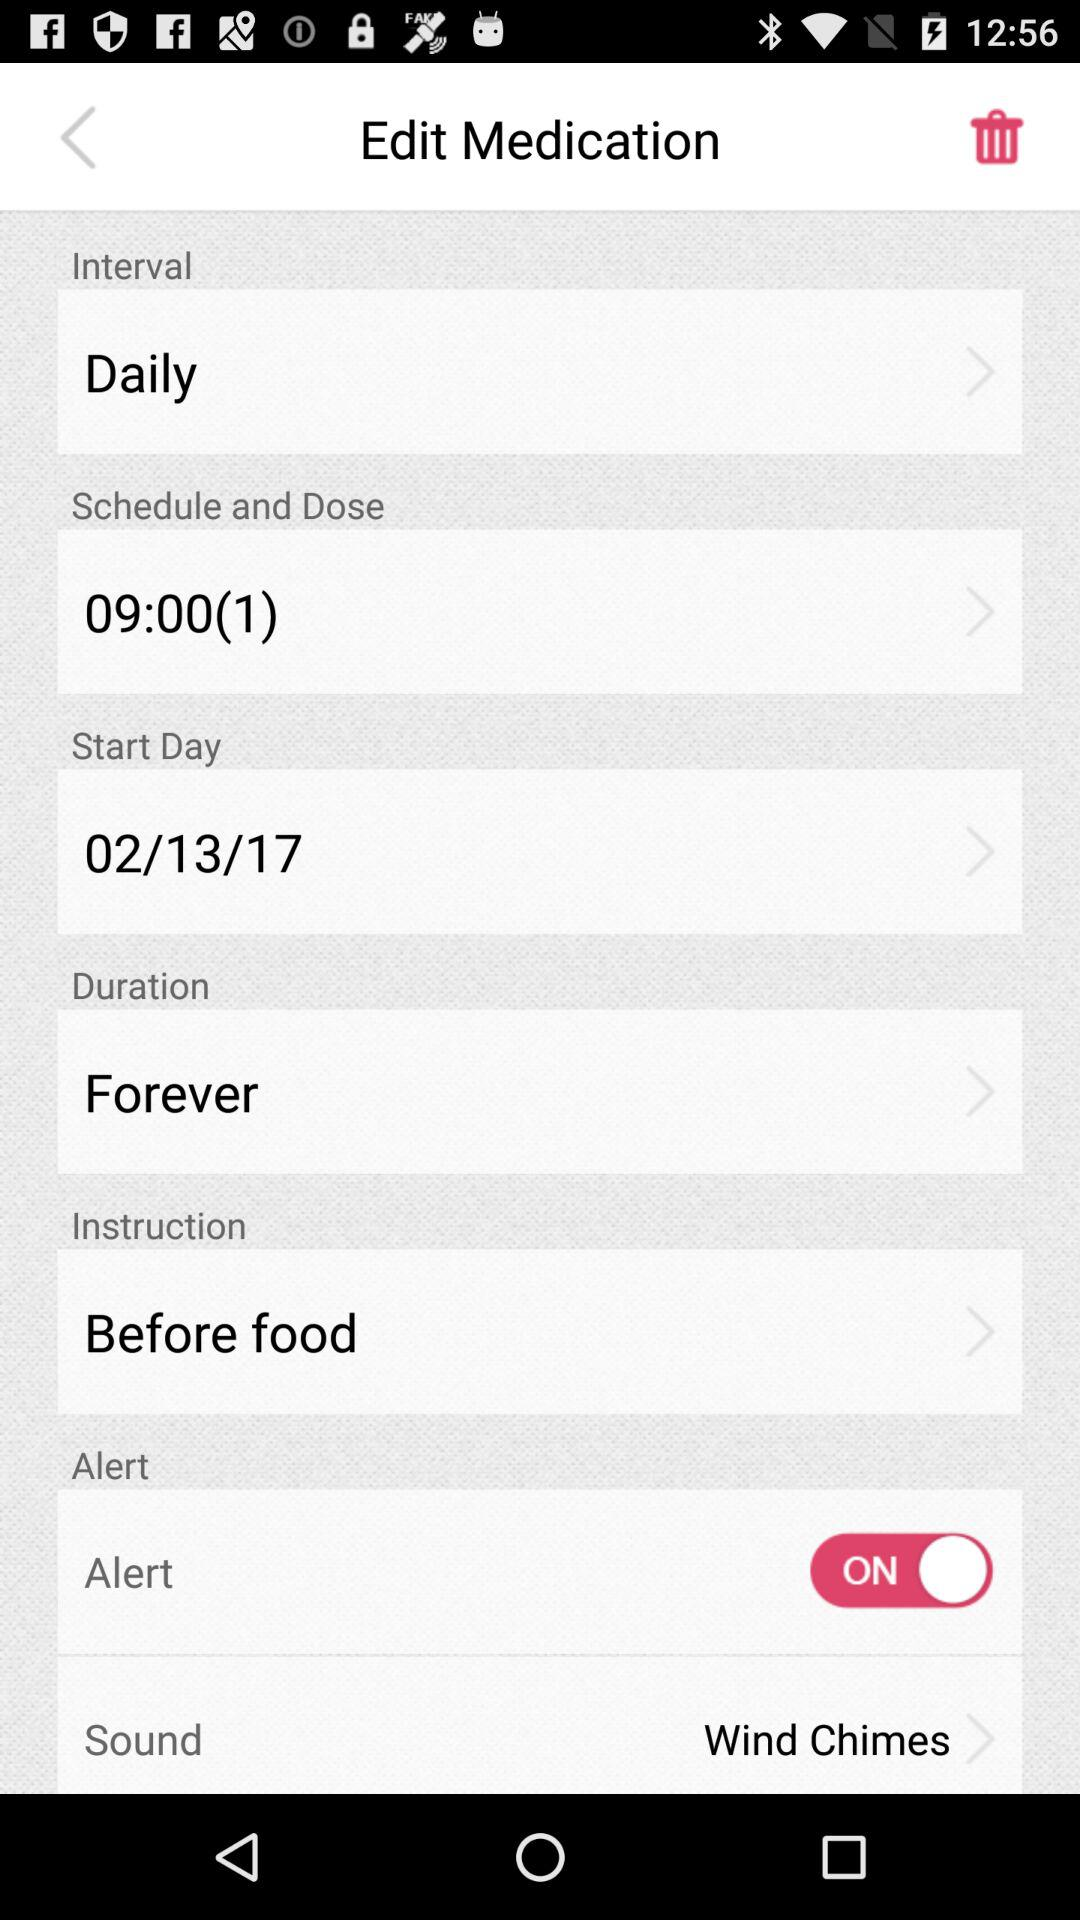What is the sound name selected for medication? The selected sound name is "Wind Chimes". 